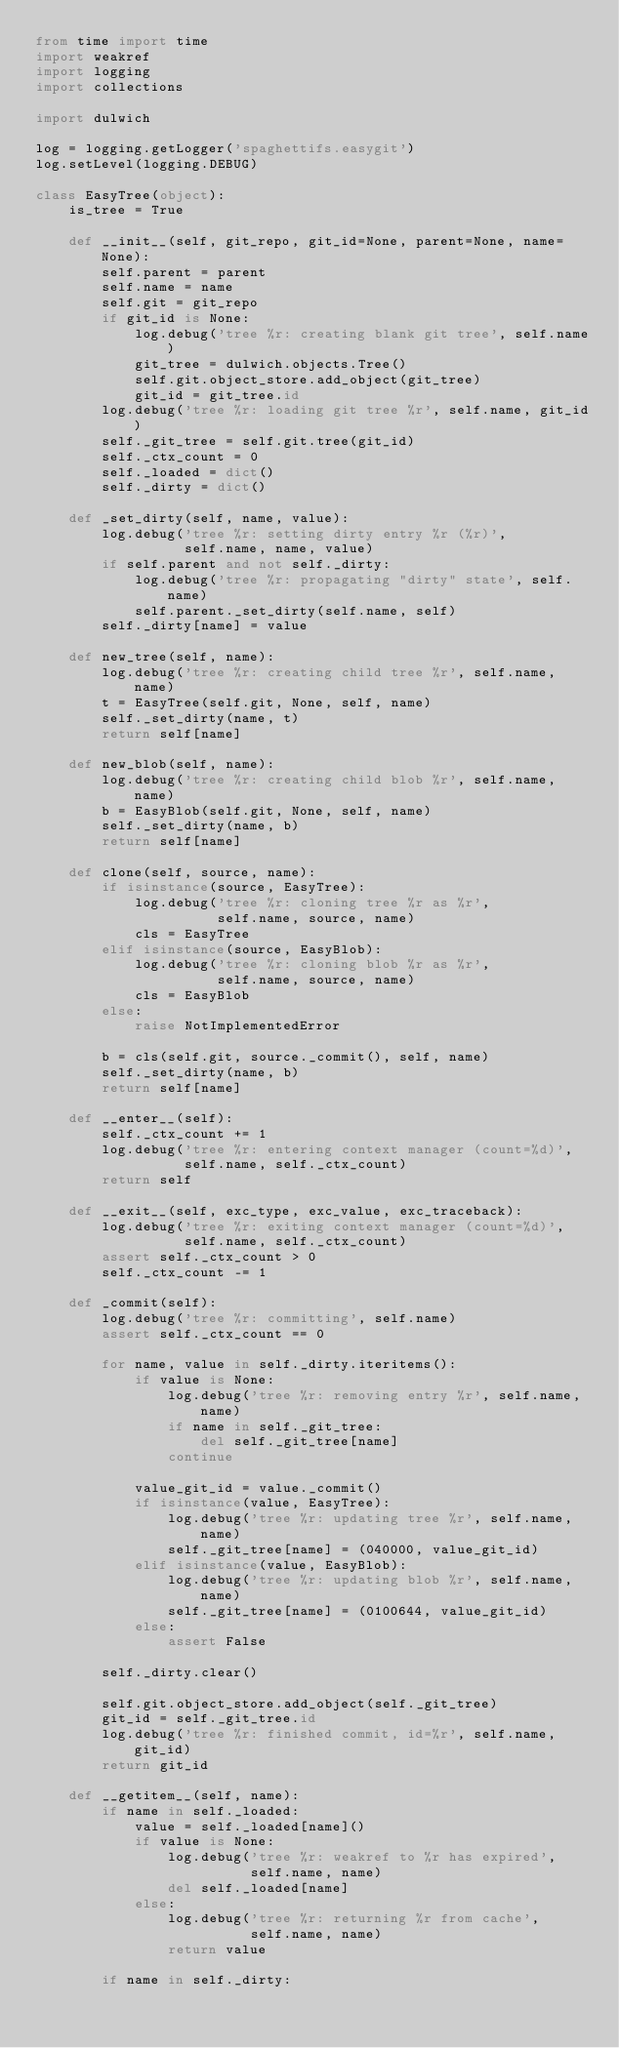Convert code to text. <code><loc_0><loc_0><loc_500><loc_500><_Python_>from time import time
import weakref
import logging
import collections

import dulwich

log = logging.getLogger('spaghettifs.easygit')
log.setLevel(logging.DEBUG)

class EasyTree(object):
    is_tree = True

    def __init__(self, git_repo, git_id=None, parent=None, name=None):
        self.parent = parent
        self.name = name
        self.git = git_repo
        if git_id is None:
            log.debug('tree %r: creating blank git tree', self.name)
            git_tree = dulwich.objects.Tree()
            self.git.object_store.add_object(git_tree)
            git_id = git_tree.id
        log.debug('tree %r: loading git tree %r', self.name, git_id)
        self._git_tree = self.git.tree(git_id)
        self._ctx_count = 0
        self._loaded = dict()
        self._dirty = dict()

    def _set_dirty(self, name, value):
        log.debug('tree %r: setting dirty entry %r (%r)',
                  self.name, name, value)
        if self.parent and not self._dirty:
            log.debug('tree %r: propagating "dirty" state', self.name)
            self.parent._set_dirty(self.name, self)
        self._dirty[name] = value

    def new_tree(self, name):
        log.debug('tree %r: creating child tree %r', self.name, name)
        t = EasyTree(self.git, None, self, name)
        self._set_dirty(name, t)
        return self[name]

    def new_blob(self, name):
        log.debug('tree %r: creating child blob %r', self.name, name)
        b = EasyBlob(self.git, None, self, name)
        self._set_dirty(name, b)
        return self[name]

    def clone(self, source, name):
        if isinstance(source, EasyTree):
            log.debug('tree %r: cloning tree %r as %r',
                      self.name, source, name)
            cls = EasyTree
        elif isinstance(source, EasyBlob):
            log.debug('tree %r: cloning blob %r as %r',
                      self.name, source, name)
            cls = EasyBlob
        else:
            raise NotImplementedError

        b = cls(self.git, source._commit(), self, name)
        self._set_dirty(name, b)
        return self[name]

    def __enter__(self):
        self._ctx_count += 1
        log.debug('tree %r: entering context manager (count=%d)',
                  self.name, self._ctx_count)
        return self

    def __exit__(self, exc_type, exc_value, exc_traceback):
        log.debug('tree %r: exiting context manager (count=%d)',
                  self.name, self._ctx_count)
        assert self._ctx_count > 0
        self._ctx_count -= 1

    def _commit(self):
        log.debug('tree %r: committing', self.name)
        assert self._ctx_count == 0

        for name, value in self._dirty.iteritems():
            if value is None:
                log.debug('tree %r: removing entry %r', self.name, name)
                if name in self._git_tree:
                    del self._git_tree[name]
                continue

            value_git_id = value._commit()
            if isinstance(value, EasyTree):
                log.debug('tree %r: updating tree %r', self.name, name)
                self._git_tree[name] = (040000, value_git_id)
            elif isinstance(value, EasyBlob):
                log.debug('tree %r: updating blob %r', self.name, name)
                self._git_tree[name] = (0100644, value_git_id)
            else:
                assert False

        self._dirty.clear()

        self.git.object_store.add_object(self._git_tree)
        git_id = self._git_tree.id
        log.debug('tree %r: finished commit, id=%r', self.name, git_id)
        return git_id

    def __getitem__(self, name):
        if name in self._loaded:
            value = self._loaded[name]()
            if value is None:
                log.debug('tree %r: weakref to %r has expired',
                          self.name, name)
                del self._loaded[name]
            else:
                log.debug('tree %r: returning %r from cache',
                          self.name, name)
                return value

        if name in self._dirty:</code> 